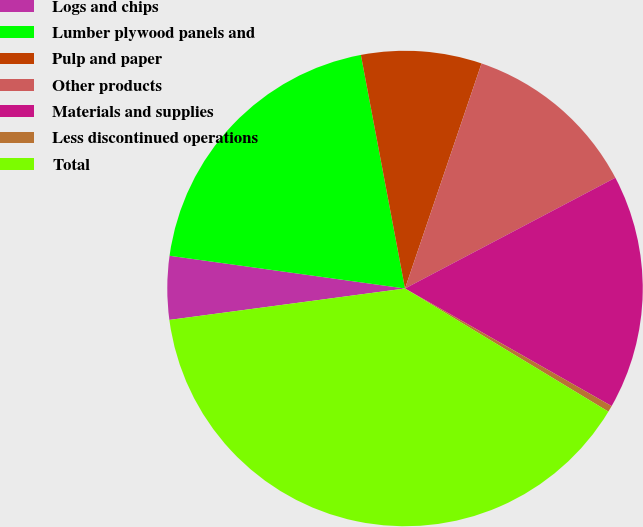<chart> <loc_0><loc_0><loc_500><loc_500><pie_chart><fcel>Logs and chips<fcel>Lumber plywood panels and<fcel>Pulp and paper<fcel>Other products<fcel>Materials and supplies<fcel>Less discontinued operations<fcel>Total<nl><fcel>4.31%<fcel>19.83%<fcel>8.19%<fcel>12.07%<fcel>15.95%<fcel>0.43%<fcel>39.23%<nl></chart> 